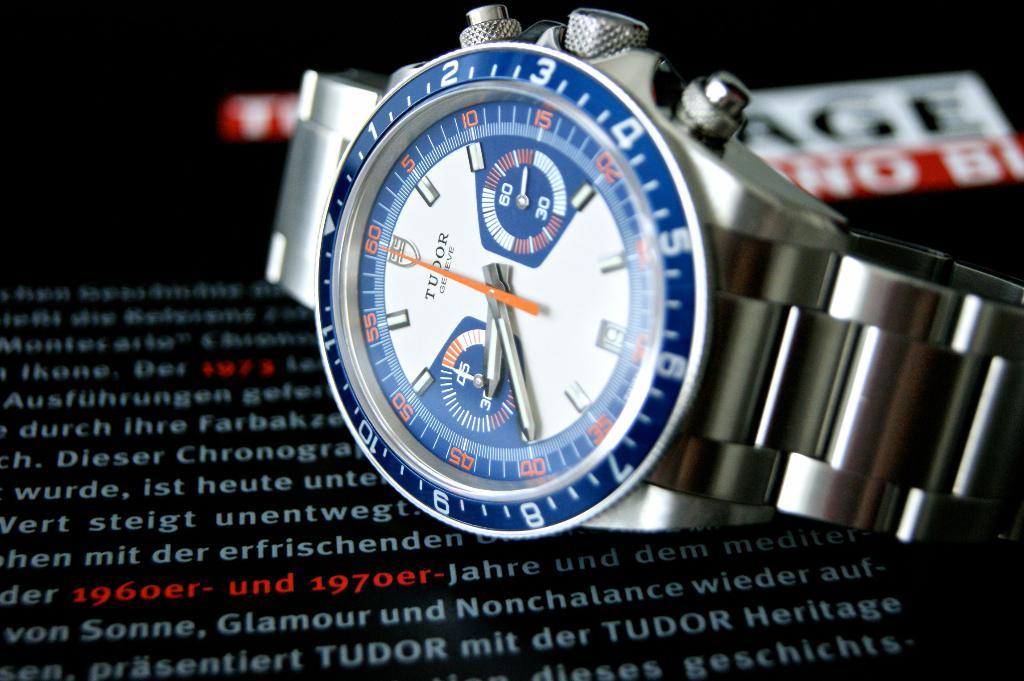What type of watch is that?
Your answer should be compact. Tudor. What time is it?
Offer a very short reply. 8:40. 